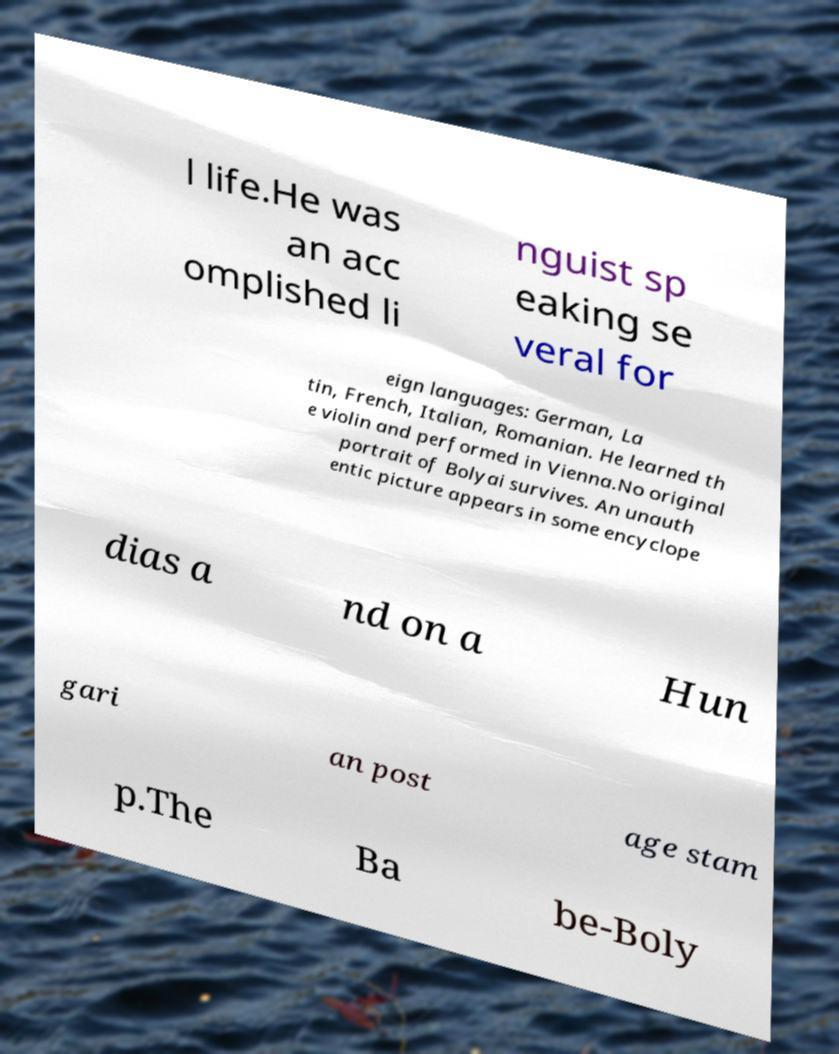Can you accurately transcribe the text from the provided image for me? l life.He was an acc omplished li nguist sp eaking se veral for eign languages: German, La tin, French, Italian, Romanian. He learned th e violin and performed in Vienna.No original portrait of Bolyai survives. An unauth entic picture appears in some encyclope dias a nd on a Hun gari an post age stam p.The Ba be-Boly 